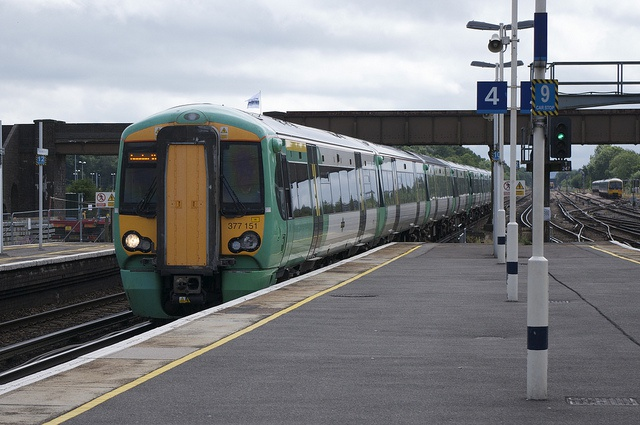Describe the objects in this image and their specific colors. I can see train in lightgray, black, gray, darkgray, and olive tones, traffic light in lightgray, black, gray, and lightblue tones, and train in lightgray, black, gray, and olive tones in this image. 